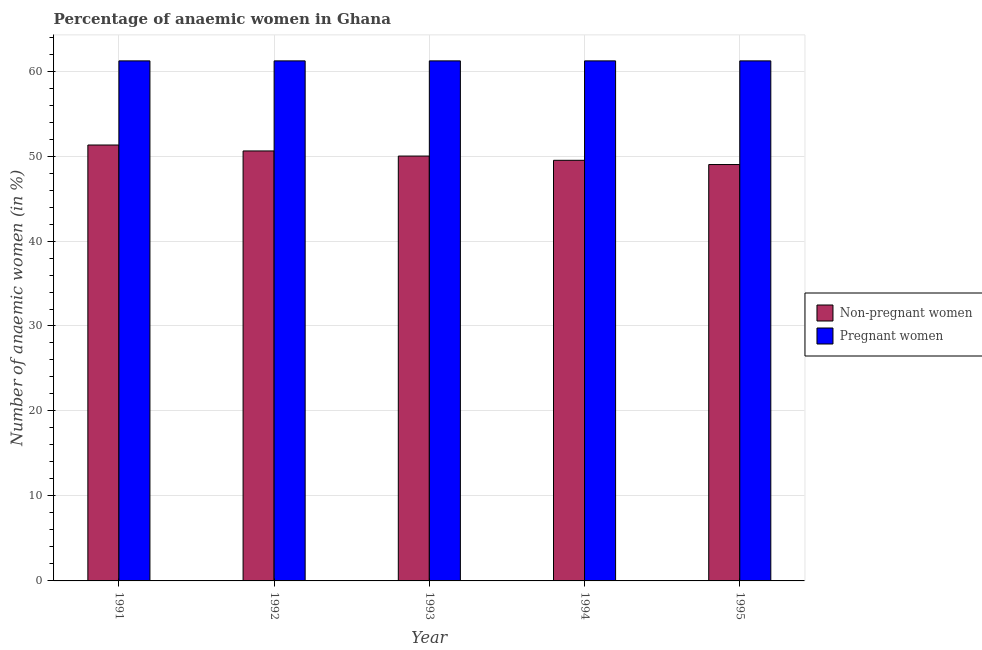What is the label of the 1st group of bars from the left?
Your answer should be compact. 1991. What is the percentage of pregnant anaemic women in 1991?
Offer a terse response. 61.2. Across all years, what is the maximum percentage of pregnant anaemic women?
Offer a terse response. 61.2. Across all years, what is the minimum percentage of pregnant anaemic women?
Your answer should be very brief. 61.2. In which year was the percentage of non-pregnant anaemic women maximum?
Offer a very short reply. 1991. What is the total percentage of pregnant anaemic women in the graph?
Your answer should be compact. 306. What is the difference between the percentage of non-pregnant anaemic women in 1991 and that in 1994?
Your response must be concise. 1.8. What is the difference between the percentage of non-pregnant anaemic women in 1993 and the percentage of pregnant anaemic women in 1995?
Your answer should be compact. 1. What is the average percentage of non-pregnant anaemic women per year?
Make the answer very short. 50.08. In the year 1995, what is the difference between the percentage of non-pregnant anaemic women and percentage of pregnant anaemic women?
Provide a succinct answer. 0. What is the ratio of the percentage of non-pregnant anaemic women in 1994 to that in 1995?
Offer a terse response. 1.01. What is the difference between the highest and the second highest percentage of non-pregnant anaemic women?
Your answer should be compact. 0.7. Is the sum of the percentage of non-pregnant anaemic women in 1994 and 1995 greater than the maximum percentage of pregnant anaemic women across all years?
Make the answer very short. Yes. What does the 2nd bar from the left in 1994 represents?
Offer a terse response. Pregnant women. What does the 1st bar from the right in 1993 represents?
Make the answer very short. Pregnant women. Are all the bars in the graph horizontal?
Give a very brief answer. No. What is the difference between two consecutive major ticks on the Y-axis?
Your response must be concise. 10. Are the values on the major ticks of Y-axis written in scientific E-notation?
Make the answer very short. No. Where does the legend appear in the graph?
Make the answer very short. Center right. What is the title of the graph?
Offer a very short reply. Percentage of anaemic women in Ghana. Does "Foreign liabilities" appear as one of the legend labels in the graph?
Offer a terse response. No. What is the label or title of the Y-axis?
Your answer should be very brief. Number of anaemic women (in %). What is the Number of anaemic women (in %) of Non-pregnant women in 1991?
Give a very brief answer. 51.3. What is the Number of anaemic women (in %) of Pregnant women in 1991?
Your response must be concise. 61.2. What is the Number of anaemic women (in %) of Non-pregnant women in 1992?
Keep it short and to the point. 50.6. What is the Number of anaemic women (in %) in Pregnant women in 1992?
Your answer should be very brief. 61.2. What is the Number of anaemic women (in %) in Non-pregnant women in 1993?
Offer a terse response. 50. What is the Number of anaemic women (in %) of Pregnant women in 1993?
Offer a terse response. 61.2. What is the Number of anaemic women (in %) of Non-pregnant women in 1994?
Offer a terse response. 49.5. What is the Number of anaemic women (in %) in Pregnant women in 1994?
Keep it short and to the point. 61.2. What is the Number of anaemic women (in %) of Non-pregnant women in 1995?
Offer a very short reply. 49. What is the Number of anaemic women (in %) in Pregnant women in 1995?
Provide a short and direct response. 61.2. Across all years, what is the maximum Number of anaemic women (in %) of Non-pregnant women?
Make the answer very short. 51.3. Across all years, what is the maximum Number of anaemic women (in %) of Pregnant women?
Provide a short and direct response. 61.2. Across all years, what is the minimum Number of anaemic women (in %) of Non-pregnant women?
Your answer should be very brief. 49. Across all years, what is the minimum Number of anaemic women (in %) of Pregnant women?
Offer a very short reply. 61.2. What is the total Number of anaemic women (in %) in Non-pregnant women in the graph?
Provide a short and direct response. 250.4. What is the total Number of anaemic women (in %) in Pregnant women in the graph?
Provide a short and direct response. 306. What is the difference between the Number of anaemic women (in %) in Non-pregnant women in 1991 and that in 1992?
Offer a very short reply. 0.7. What is the difference between the Number of anaemic women (in %) in Pregnant women in 1991 and that in 1992?
Your answer should be compact. 0. What is the difference between the Number of anaemic women (in %) in Pregnant women in 1991 and that in 1993?
Your response must be concise. 0. What is the difference between the Number of anaemic women (in %) of Non-pregnant women in 1991 and that in 1994?
Offer a terse response. 1.8. What is the difference between the Number of anaemic women (in %) in Non-pregnant women in 1991 and that in 1995?
Offer a very short reply. 2.3. What is the difference between the Number of anaemic women (in %) of Pregnant women in 1991 and that in 1995?
Provide a succinct answer. 0. What is the difference between the Number of anaemic women (in %) in Non-pregnant women in 1992 and that in 1993?
Your answer should be very brief. 0.6. What is the difference between the Number of anaemic women (in %) in Pregnant women in 1992 and that in 1994?
Offer a terse response. 0. What is the difference between the Number of anaemic women (in %) in Non-pregnant women in 1992 and that in 1995?
Offer a very short reply. 1.6. What is the difference between the Number of anaemic women (in %) of Pregnant women in 1992 and that in 1995?
Provide a succinct answer. 0. What is the difference between the Number of anaemic women (in %) of Pregnant women in 1993 and that in 1995?
Your answer should be very brief. 0. What is the difference between the Number of anaemic women (in %) in Pregnant women in 1994 and that in 1995?
Make the answer very short. 0. What is the difference between the Number of anaemic women (in %) in Non-pregnant women in 1991 and the Number of anaemic women (in %) in Pregnant women in 1992?
Offer a terse response. -9.9. What is the difference between the Number of anaemic women (in %) of Non-pregnant women in 1991 and the Number of anaemic women (in %) of Pregnant women in 1993?
Provide a succinct answer. -9.9. What is the difference between the Number of anaemic women (in %) of Non-pregnant women in 1991 and the Number of anaemic women (in %) of Pregnant women in 1994?
Your response must be concise. -9.9. What is the difference between the Number of anaemic women (in %) of Non-pregnant women in 1991 and the Number of anaemic women (in %) of Pregnant women in 1995?
Your answer should be very brief. -9.9. What is the difference between the Number of anaemic women (in %) in Non-pregnant women in 1992 and the Number of anaemic women (in %) in Pregnant women in 1993?
Make the answer very short. -10.6. What is the difference between the Number of anaemic women (in %) in Non-pregnant women in 1992 and the Number of anaemic women (in %) in Pregnant women in 1994?
Offer a very short reply. -10.6. What is the difference between the Number of anaemic women (in %) of Non-pregnant women in 1992 and the Number of anaemic women (in %) of Pregnant women in 1995?
Keep it short and to the point. -10.6. What is the difference between the Number of anaemic women (in %) in Non-pregnant women in 1993 and the Number of anaemic women (in %) in Pregnant women in 1994?
Provide a succinct answer. -11.2. What is the difference between the Number of anaemic women (in %) of Non-pregnant women in 1993 and the Number of anaemic women (in %) of Pregnant women in 1995?
Offer a very short reply. -11.2. What is the difference between the Number of anaemic women (in %) of Non-pregnant women in 1994 and the Number of anaemic women (in %) of Pregnant women in 1995?
Provide a short and direct response. -11.7. What is the average Number of anaemic women (in %) in Non-pregnant women per year?
Provide a short and direct response. 50.08. What is the average Number of anaemic women (in %) of Pregnant women per year?
Ensure brevity in your answer.  61.2. In the year 1992, what is the difference between the Number of anaemic women (in %) in Non-pregnant women and Number of anaemic women (in %) in Pregnant women?
Provide a short and direct response. -10.6. What is the ratio of the Number of anaemic women (in %) in Non-pregnant women in 1991 to that in 1992?
Your answer should be compact. 1.01. What is the ratio of the Number of anaemic women (in %) in Non-pregnant women in 1991 to that in 1993?
Provide a short and direct response. 1.03. What is the ratio of the Number of anaemic women (in %) of Non-pregnant women in 1991 to that in 1994?
Offer a very short reply. 1.04. What is the ratio of the Number of anaemic women (in %) of Non-pregnant women in 1991 to that in 1995?
Provide a succinct answer. 1.05. What is the ratio of the Number of anaemic women (in %) of Pregnant women in 1991 to that in 1995?
Keep it short and to the point. 1. What is the ratio of the Number of anaemic women (in %) in Non-pregnant women in 1992 to that in 1994?
Keep it short and to the point. 1.02. What is the ratio of the Number of anaemic women (in %) in Non-pregnant women in 1992 to that in 1995?
Your response must be concise. 1.03. What is the ratio of the Number of anaemic women (in %) in Pregnant women in 1992 to that in 1995?
Provide a succinct answer. 1. What is the ratio of the Number of anaemic women (in %) of Non-pregnant women in 1993 to that in 1994?
Give a very brief answer. 1.01. What is the ratio of the Number of anaemic women (in %) in Pregnant women in 1993 to that in 1994?
Offer a terse response. 1. What is the ratio of the Number of anaemic women (in %) of Non-pregnant women in 1993 to that in 1995?
Your response must be concise. 1.02. What is the ratio of the Number of anaemic women (in %) in Non-pregnant women in 1994 to that in 1995?
Provide a succinct answer. 1.01. What is the difference between the highest and the second highest Number of anaemic women (in %) of Pregnant women?
Keep it short and to the point. 0. What is the difference between the highest and the lowest Number of anaemic women (in %) of Non-pregnant women?
Offer a terse response. 2.3. What is the difference between the highest and the lowest Number of anaemic women (in %) of Pregnant women?
Your response must be concise. 0. 